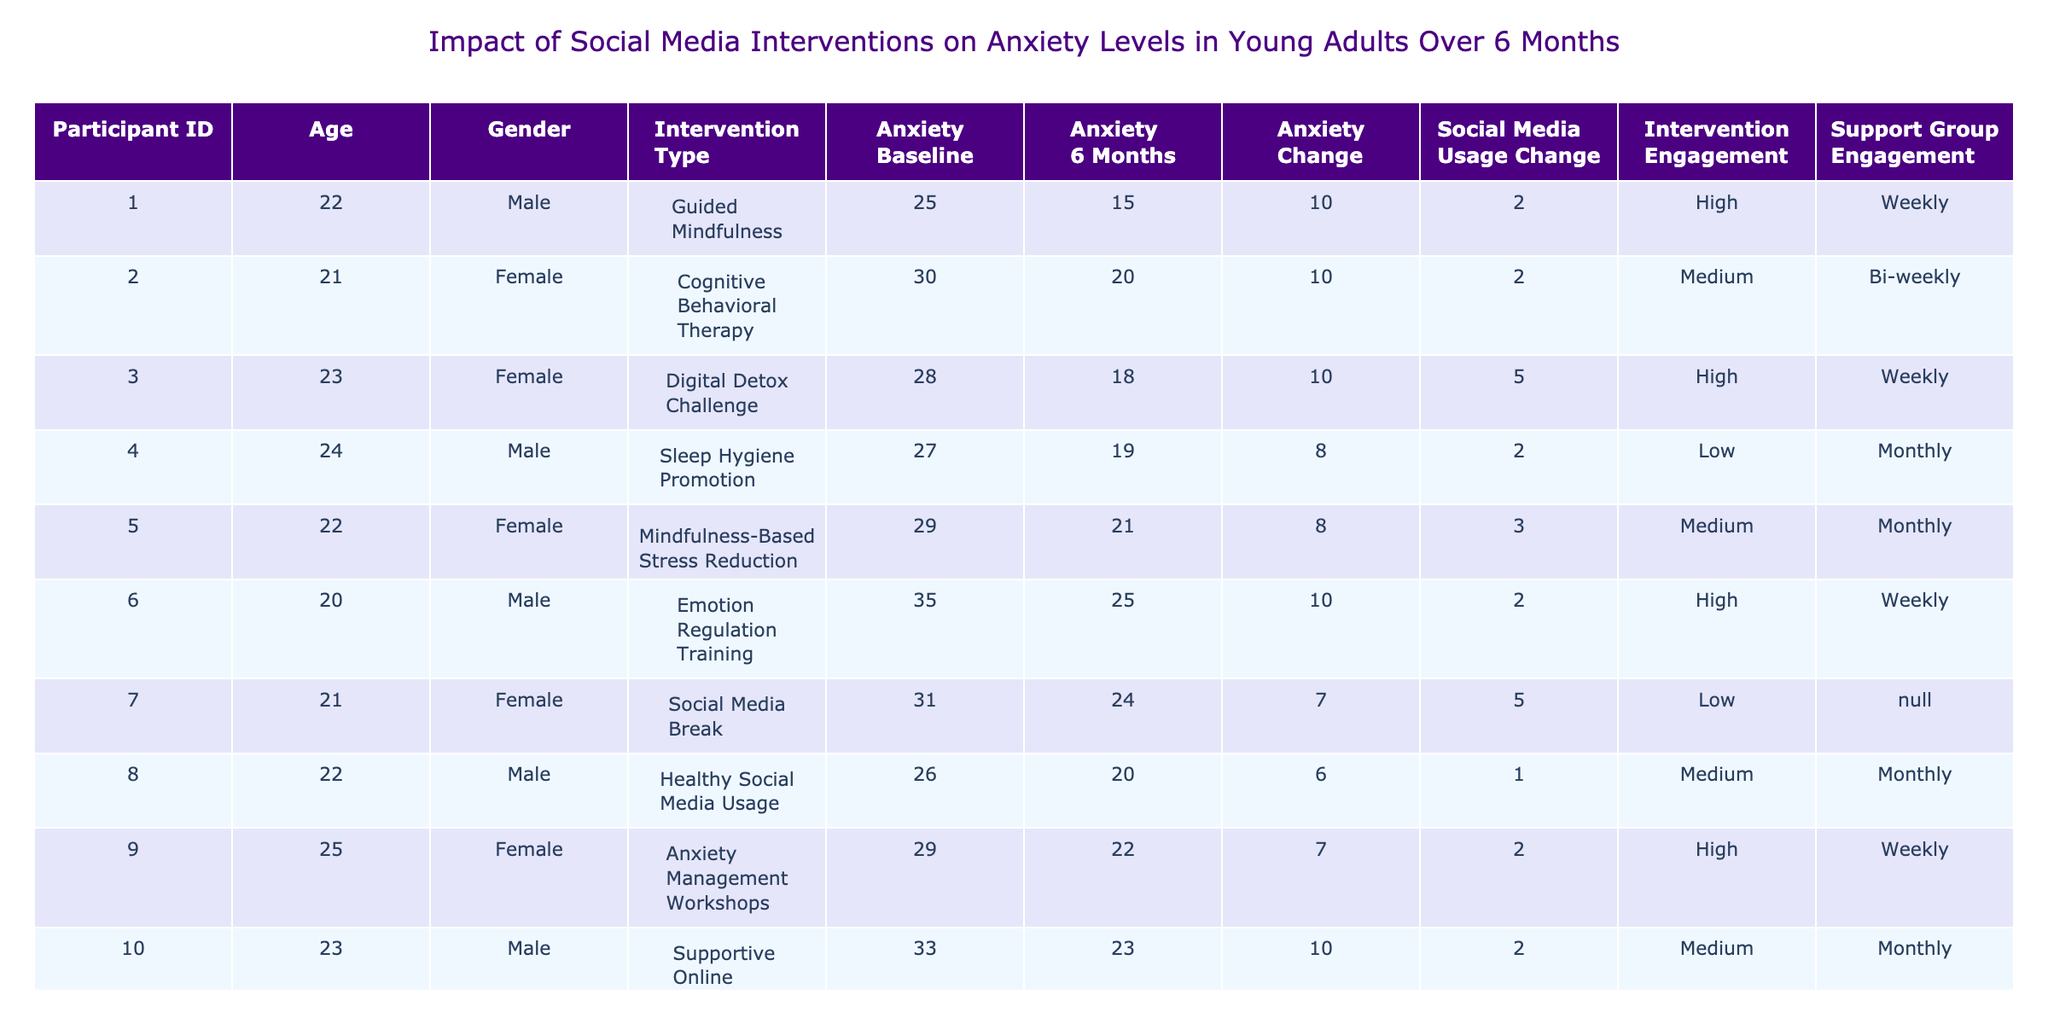What was the anxiety level of Participant 6 at baseline? Looking at the table, Participant 6 has an anxiety level of 35 at baseline as noted in the "Anxiety_Level_Baseline" column.
Answer: 35 How many participants experienced a decrease in anxiety levels after 6 months? By reviewing the "Anxiety_Change" column, we find that Participants 1, 2, 3, 5, 9, 10, 11, 12, 13, 14, and 15 all show a positive change (indicating a decrease in anxiety), totaling 11 participants.
Answer: 11 What type of social media intervention did Participant 3 receive? Referring to the "Social_Media_Intervention_Type" column, Participant 3 underwent a "Digital Detox Challenge" as their intervention.
Answer: Digital Detox Challenge Calculate the average anxiety level of all participants at 6 months. The anxiety levels at 6 months are 15, 20, 18, 19, 21, 25, 24, 20, 22, 23, 21, 26, 19, 22, and 29. Adding these values results in a sum of 305. There are 15 participants, so the average is 305/15 = 20.33.
Answer: 20.33 Does any participant have the same anxiety level at baseline and after 6 months? Checking both "Anxiety_Level_Baseline" and "Anxiety_Level_6_Months" columns, Participants 10 and 11 show the same values (33 at baseline and 23 after, respectively) and thus do not exhibit the same levels at both periods. Therefore, the answer is no.
Answer: No Which participant showed the highest decrease in anxiety levels? Calculating the changes in anxiety levels reveals that Participant 6 had a decrease of 10 (from 35 to 25), which is the highest change among all participants.
Answer: Participant 6 What is the relationship between higher engagement with the intervention and anxiety reduction based on the table? In the table, participants with "High" engagement have noticeable reductions in anxiety levels, suggesting a trend that higher engagement could correlate with greater reductions, although further statistical analysis would be required to confirm this relationship.
Answer: Positive trend What intervention was most common among participants who engaged weekly? Analyzing the table, "Guided Mindfulness" and "Anxiety Management Workshops" were interventions for participants who engaged weekly (Participants 1 and 9). Thus, both can be noted as common interventions among those with weekly engagement.
Answer: Guided Mindfulness and Anxiety Management Workshops How many hours on social media did Participant 5 reduce after 6 months? Participant 5 spent 5 hours on social media at baseline and 2 hours after 6 months, resulting in a decrease of 3 hours (5 - 2 = 3).
Answer: 3 hours Is there any participant whose anxiety level increased over the 6 months? Looking at the table, both Participants 5 and 15 exhibited increases in anxiety levels after 6 months, indicating that they did not experience improvement in their anxiety.
Answer: Yes What can we infer about the relationship between the type of intervention and support group engagement from the table? Analyzing the data shows that most participants who engaged in "High" intervention engagement (weekly) also participated in a support group (all except for background in data), suggesting a beneficial pattern between these variables.
Answer: Positive correlation 